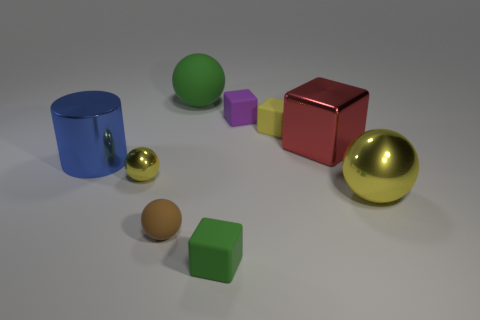Subtract all tiny cubes. How many cubes are left? 1 Subtract all cylinders. How many objects are left? 8 Subtract all tiny matte blocks. Subtract all rubber cubes. How many objects are left? 3 Add 3 big red shiny cubes. How many big red shiny cubes are left? 4 Add 1 red things. How many red things exist? 2 Add 1 purple rubber things. How many objects exist? 10 Subtract all green cubes. How many cubes are left? 3 Subtract 0 cyan balls. How many objects are left? 9 Subtract 3 cubes. How many cubes are left? 1 Subtract all brown cylinders. Subtract all red spheres. How many cylinders are left? 1 